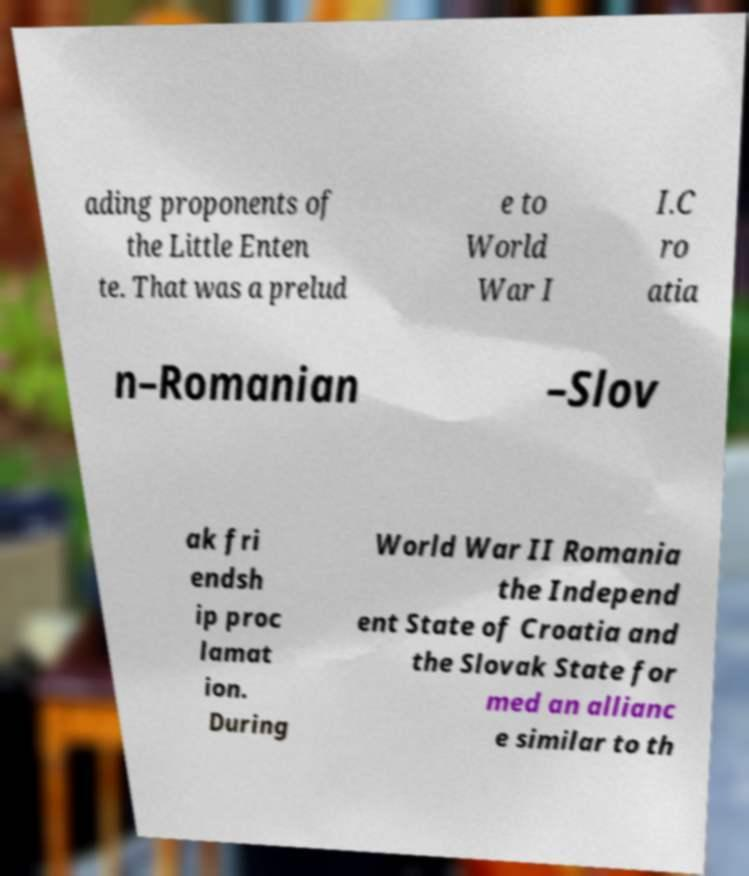Please identify and transcribe the text found in this image. ading proponents of the Little Enten te. That was a prelud e to World War I I.C ro atia n–Romanian –Slov ak fri endsh ip proc lamat ion. During World War II Romania the Independ ent State of Croatia and the Slovak State for med an allianc e similar to th 